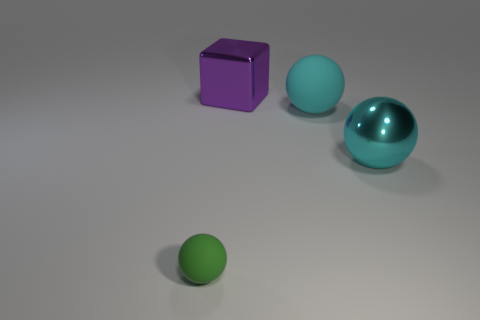Add 4 large purple blocks. How many objects exist? 8 Subtract all spheres. How many objects are left? 1 Add 4 small green things. How many small green things exist? 5 Subtract 0 red balls. How many objects are left? 4 Subtract all big cyan metallic spheres. Subtract all big metallic balls. How many objects are left? 2 Add 1 green matte objects. How many green matte objects are left? 2 